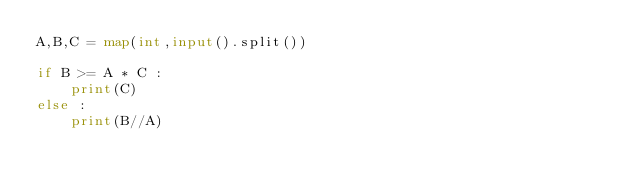<code> <loc_0><loc_0><loc_500><loc_500><_Python_>A,B,C = map(int,input().split())

if B >= A * C :
    print(C)
else :
    print(B//A)
    </code> 